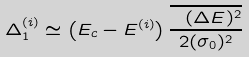<formula> <loc_0><loc_0><loc_500><loc_500>\Delta _ { 1 } ^ { ( i ) } \simeq \left ( E _ { c } - E ^ { ( i ) } \right ) \frac { \overline { \ ( \Delta E ) ^ { 2 } } } { 2 ( \sigma _ { 0 } ) ^ { 2 } }</formula> 